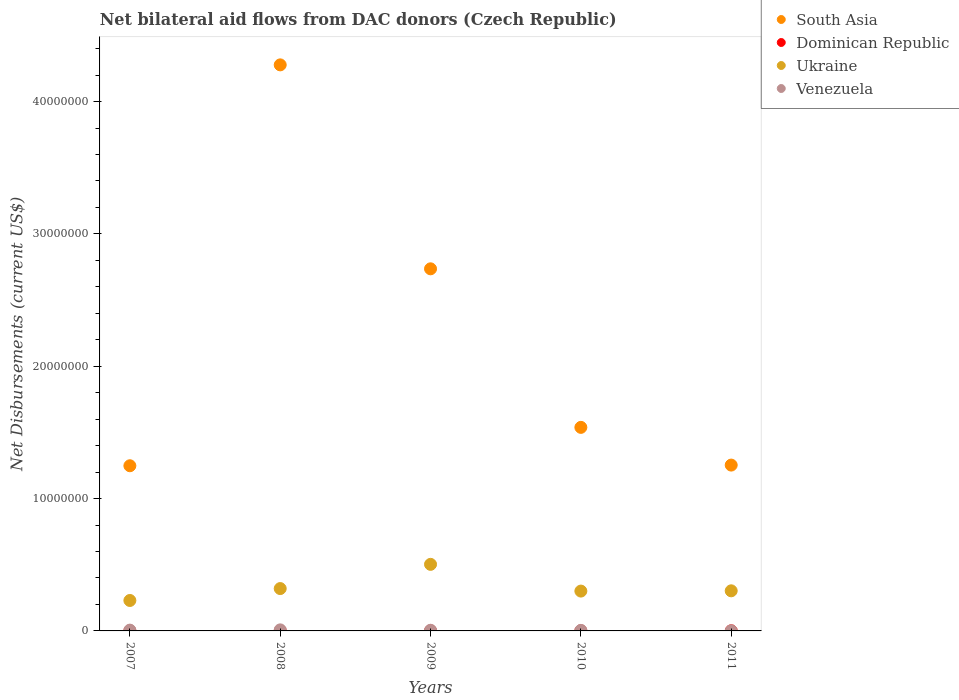What is the net bilateral aid flows in Ukraine in 2007?
Keep it short and to the point. 2.30e+06. Across all years, what is the minimum net bilateral aid flows in Ukraine?
Your response must be concise. 2.30e+06. In which year was the net bilateral aid flows in South Asia maximum?
Your answer should be compact. 2008. What is the total net bilateral aid flows in Ukraine in the graph?
Make the answer very short. 1.66e+07. What is the difference between the net bilateral aid flows in Ukraine in 2011 and the net bilateral aid flows in Venezuela in 2010?
Ensure brevity in your answer.  2.99e+06. What is the average net bilateral aid flows in Ukraine per year?
Offer a terse response. 3.31e+06. In the year 2007, what is the difference between the net bilateral aid flows in Dominican Republic and net bilateral aid flows in Venezuela?
Offer a terse response. -5.00e+04. In how many years, is the net bilateral aid flows in Ukraine greater than 28000000 US$?
Offer a very short reply. 0. What is the ratio of the net bilateral aid flows in South Asia in 2007 to that in 2011?
Your answer should be very brief. 1. Is the net bilateral aid flows in Venezuela in 2007 less than that in 2008?
Ensure brevity in your answer.  Yes. Is the difference between the net bilateral aid flows in Dominican Republic in 2007 and 2010 greater than the difference between the net bilateral aid flows in Venezuela in 2007 and 2010?
Offer a terse response. No. What is the difference between the highest and the second highest net bilateral aid flows in Ukraine?
Your answer should be very brief. 1.83e+06. In how many years, is the net bilateral aid flows in Venezuela greater than the average net bilateral aid flows in Venezuela taken over all years?
Offer a terse response. 3. Is the sum of the net bilateral aid flows in Venezuela in 2008 and 2011 greater than the maximum net bilateral aid flows in Dominican Republic across all years?
Your response must be concise. Yes. Is it the case that in every year, the sum of the net bilateral aid flows in Venezuela and net bilateral aid flows in Ukraine  is greater than the sum of net bilateral aid flows in Dominican Republic and net bilateral aid flows in South Asia?
Provide a short and direct response. Yes. Is it the case that in every year, the sum of the net bilateral aid flows in Venezuela and net bilateral aid flows in South Asia  is greater than the net bilateral aid flows in Dominican Republic?
Keep it short and to the point. Yes. Does the net bilateral aid flows in Ukraine monotonically increase over the years?
Your answer should be compact. No. Is the net bilateral aid flows in Ukraine strictly less than the net bilateral aid flows in Dominican Republic over the years?
Offer a very short reply. No. What is the difference between two consecutive major ticks on the Y-axis?
Give a very brief answer. 1.00e+07. Are the values on the major ticks of Y-axis written in scientific E-notation?
Provide a succinct answer. No. Does the graph contain grids?
Provide a short and direct response. No. How many legend labels are there?
Ensure brevity in your answer.  4. What is the title of the graph?
Provide a succinct answer. Net bilateral aid flows from DAC donors (Czech Republic). Does "Guinea" appear as one of the legend labels in the graph?
Keep it short and to the point. No. What is the label or title of the Y-axis?
Ensure brevity in your answer.  Net Disbursements (current US$). What is the Net Disbursements (current US$) in South Asia in 2007?
Make the answer very short. 1.25e+07. What is the Net Disbursements (current US$) of Dominican Republic in 2007?
Keep it short and to the point. 10000. What is the Net Disbursements (current US$) in Ukraine in 2007?
Your answer should be compact. 2.30e+06. What is the Net Disbursements (current US$) of Venezuela in 2007?
Your response must be concise. 6.00e+04. What is the Net Disbursements (current US$) of South Asia in 2008?
Provide a succinct answer. 4.28e+07. What is the Net Disbursements (current US$) of Dominican Republic in 2008?
Make the answer very short. 10000. What is the Net Disbursements (current US$) of Ukraine in 2008?
Keep it short and to the point. 3.20e+06. What is the Net Disbursements (current US$) in Venezuela in 2008?
Your response must be concise. 8.00e+04. What is the Net Disbursements (current US$) in South Asia in 2009?
Keep it short and to the point. 2.74e+07. What is the Net Disbursements (current US$) of Dominican Republic in 2009?
Make the answer very short. 10000. What is the Net Disbursements (current US$) of Ukraine in 2009?
Provide a succinct answer. 5.03e+06. What is the Net Disbursements (current US$) in South Asia in 2010?
Your answer should be very brief. 1.54e+07. What is the Net Disbursements (current US$) of Ukraine in 2010?
Your answer should be compact. 3.01e+06. What is the Net Disbursements (current US$) of South Asia in 2011?
Make the answer very short. 1.25e+07. What is the Net Disbursements (current US$) of Dominican Republic in 2011?
Offer a very short reply. 10000. What is the Net Disbursements (current US$) of Ukraine in 2011?
Keep it short and to the point. 3.03e+06. Across all years, what is the maximum Net Disbursements (current US$) in South Asia?
Your response must be concise. 4.28e+07. Across all years, what is the maximum Net Disbursements (current US$) of Dominican Republic?
Offer a very short reply. 10000. Across all years, what is the maximum Net Disbursements (current US$) in Ukraine?
Offer a terse response. 5.03e+06. Across all years, what is the maximum Net Disbursements (current US$) in Venezuela?
Give a very brief answer. 8.00e+04. Across all years, what is the minimum Net Disbursements (current US$) in South Asia?
Keep it short and to the point. 1.25e+07. Across all years, what is the minimum Net Disbursements (current US$) in Ukraine?
Offer a very short reply. 2.30e+06. What is the total Net Disbursements (current US$) of South Asia in the graph?
Make the answer very short. 1.11e+08. What is the total Net Disbursements (current US$) in Dominican Republic in the graph?
Give a very brief answer. 5.00e+04. What is the total Net Disbursements (current US$) of Ukraine in the graph?
Make the answer very short. 1.66e+07. What is the total Net Disbursements (current US$) in Venezuela in the graph?
Provide a short and direct response. 2.40e+05. What is the difference between the Net Disbursements (current US$) in South Asia in 2007 and that in 2008?
Offer a terse response. -3.03e+07. What is the difference between the Net Disbursements (current US$) in Ukraine in 2007 and that in 2008?
Offer a terse response. -9.00e+05. What is the difference between the Net Disbursements (current US$) of Venezuela in 2007 and that in 2008?
Your answer should be very brief. -2.00e+04. What is the difference between the Net Disbursements (current US$) of South Asia in 2007 and that in 2009?
Your answer should be very brief. -1.49e+07. What is the difference between the Net Disbursements (current US$) of Ukraine in 2007 and that in 2009?
Make the answer very short. -2.73e+06. What is the difference between the Net Disbursements (current US$) of South Asia in 2007 and that in 2010?
Provide a succinct answer. -2.90e+06. What is the difference between the Net Disbursements (current US$) of Dominican Republic in 2007 and that in 2010?
Make the answer very short. 0. What is the difference between the Net Disbursements (current US$) of Ukraine in 2007 and that in 2010?
Offer a very short reply. -7.10e+05. What is the difference between the Net Disbursements (current US$) of Venezuela in 2007 and that in 2010?
Offer a very short reply. 2.00e+04. What is the difference between the Net Disbursements (current US$) in South Asia in 2007 and that in 2011?
Offer a terse response. -5.00e+04. What is the difference between the Net Disbursements (current US$) of Dominican Republic in 2007 and that in 2011?
Give a very brief answer. 0. What is the difference between the Net Disbursements (current US$) in Ukraine in 2007 and that in 2011?
Provide a short and direct response. -7.30e+05. What is the difference between the Net Disbursements (current US$) of South Asia in 2008 and that in 2009?
Provide a short and direct response. 1.54e+07. What is the difference between the Net Disbursements (current US$) in Ukraine in 2008 and that in 2009?
Offer a terse response. -1.83e+06. What is the difference between the Net Disbursements (current US$) of Venezuela in 2008 and that in 2009?
Your answer should be compact. 3.00e+04. What is the difference between the Net Disbursements (current US$) of South Asia in 2008 and that in 2010?
Ensure brevity in your answer.  2.74e+07. What is the difference between the Net Disbursements (current US$) of Venezuela in 2008 and that in 2010?
Ensure brevity in your answer.  4.00e+04. What is the difference between the Net Disbursements (current US$) in South Asia in 2008 and that in 2011?
Keep it short and to the point. 3.02e+07. What is the difference between the Net Disbursements (current US$) in Ukraine in 2008 and that in 2011?
Make the answer very short. 1.70e+05. What is the difference between the Net Disbursements (current US$) of South Asia in 2009 and that in 2010?
Your response must be concise. 1.20e+07. What is the difference between the Net Disbursements (current US$) in Ukraine in 2009 and that in 2010?
Your answer should be compact. 2.02e+06. What is the difference between the Net Disbursements (current US$) in Venezuela in 2009 and that in 2010?
Provide a short and direct response. 10000. What is the difference between the Net Disbursements (current US$) in South Asia in 2009 and that in 2011?
Keep it short and to the point. 1.48e+07. What is the difference between the Net Disbursements (current US$) in Ukraine in 2009 and that in 2011?
Provide a succinct answer. 2.00e+06. What is the difference between the Net Disbursements (current US$) of South Asia in 2010 and that in 2011?
Your response must be concise. 2.85e+06. What is the difference between the Net Disbursements (current US$) in Ukraine in 2010 and that in 2011?
Your answer should be very brief. -2.00e+04. What is the difference between the Net Disbursements (current US$) in South Asia in 2007 and the Net Disbursements (current US$) in Dominican Republic in 2008?
Keep it short and to the point. 1.25e+07. What is the difference between the Net Disbursements (current US$) in South Asia in 2007 and the Net Disbursements (current US$) in Ukraine in 2008?
Provide a succinct answer. 9.28e+06. What is the difference between the Net Disbursements (current US$) in South Asia in 2007 and the Net Disbursements (current US$) in Venezuela in 2008?
Ensure brevity in your answer.  1.24e+07. What is the difference between the Net Disbursements (current US$) in Dominican Republic in 2007 and the Net Disbursements (current US$) in Ukraine in 2008?
Offer a very short reply. -3.19e+06. What is the difference between the Net Disbursements (current US$) of Ukraine in 2007 and the Net Disbursements (current US$) of Venezuela in 2008?
Offer a very short reply. 2.22e+06. What is the difference between the Net Disbursements (current US$) in South Asia in 2007 and the Net Disbursements (current US$) in Dominican Republic in 2009?
Provide a short and direct response. 1.25e+07. What is the difference between the Net Disbursements (current US$) of South Asia in 2007 and the Net Disbursements (current US$) of Ukraine in 2009?
Your response must be concise. 7.45e+06. What is the difference between the Net Disbursements (current US$) of South Asia in 2007 and the Net Disbursements (current US$) of Venezuela in 2009?
Your answer should be very brief. 1.24e+07. What is the difference between the Net Disbursements (current US$) in Dominican Republic in 2007 and the Net Disbursements (current US$) in Ukraine in 2009?
Keep it short and to the point. -5.02e+06. What is the difference between the Net Disbursements (current US$) of Dominican Republic in 2007 and the Net Disbursements (current US$) of Venezuela in 2009?
Provide a succinct answer. -4.00e+04. What is the difference between the Net Disbursements (current US$) of Ukraine in 2007 and the Net Disbursements (current US$) of Venezuela in 2009?
Provide a succinct answer. 2.25e+06. What is the difference between the Net Disbursements (current US$) of South Asia in 2007 and the Net Disbursements (current US$) of Dominican Republic in 2010?
Offer a very short reply. 1.25e+07. What is the difference between the Net Disbursements (current US$) in South Asia in 2007 and the Net Disbursements (current US$) in Ukraine in 2010?
Offer a very short reply. 9.47e+06. What is the difference between the Net Disbursements (current US$) in South Asia in 2007 and the Net Disbursements (current US$) in Venezuela in 2010?
Your answer should be compact. 1.24e+07. What is the difference between the Net Disbursements (current US$) of Dominican Republic in 2007 and the Net Disbursements (current US$) of Ukraine in 2010?
Give a very brief answer. -3.00e+06. What is the difference between the Net Disbursements (current US$) in Dominican Republic in 2007 and the Net Disbursements (current US$) in Venezuela in 2010?
Ensure brevity in your answer.  -3.00e+04. What is the difference between the Net Disbursements (current US$) in Ukraine in 2007 and the Net Disbursements (current US$) in Venezuela in 2010?
Your answer should be compact. 2.26e+06. What is the difference between the Net Disbursements (current US$) in South Asia in 2007 and the Net Disbursements (current US$) in Dominican Republic in 2011?
Ensure brevity in your answer.  1.25e+07. What is the difference between the Net Disbursements (current US$) in South Asia in 2007 and the Net Disbursements (current US$) in Ukraine in 2011?
Your answer should be very brief. 9.45e+06. What is the difference between the Net Disbursements (current US$) in South Asia in 2007 and the Net Disbursements (current US$) in Venezuela in 2011?
Give a very brief answer. 1.25e+07. What is the difference between the Net Disbursements (current US$) of Dominican Republic in 2007 and the Net Disbursements (current US$) of Ukraine in 2011?
Ensure brevity in your answer.  -3.02e+06. What is the difference between the Net Disbursements (current US$) of Dominican Republic in 2007 and the Net Disbursements (current US$) of Venezuela in 2011?
Provide a succinct answer. 0. What is the difference between the Net Disbursements (current US$) of Ukraine in 2007 and the Net Disbursements (current US$) of Venezuela in 2011?
Offer a very short reply. 2.29e+06. What is the difference between the Net Disbursements (current US$) of South Asia in 2008 and the Net Disbursements (current US$) of Dominican Republic in 2009?
Offer a very short reply. 4.28e+07. What is the difference between the Net Disbursements (current US$) of South Asia in 2008 and the Net Disbursements (current US$) of Ukraine in 2009?
Your answer should be compact. 3.77e+07. What is the difference between the Net Disbursements (current US$) in South Asia in 2008 and the Net Disbursements (current US$) in Venezuela in 2009?
Keep it short and to the point. 4.27e+07. What is the difference between the Net Disbursements (current US$) in Dominican Republic in 2008 and the Net Disbursements (current US$) in Ukraine in 2009?
Provide a succinct answer. -5.02e+06. What is the difference between the Net Disbursements (current US$) of Ukraine in 2008 and the Net Disbursements (current US$) of Venezuela in 2009?
Your answer should be very brief. 3.15e+06. What is the difference between the Net Disbursements (current US$) of South Asia in 2008 and the Net Disbursements (current US$) of Dominican Republic in 2010?
Provide a short and direct response. 4.28e+07. What is the difference between the Net Disbursements (current US$) of South Asia in 2008 and the Net Disbursements (current US$) of Ukraine in 2010?
Your answer should be very brief. 3.98e+07. What is the difference between the Net Disbursements (current US$) of South Asia in 2008 and the Net Disbursements (current US$) of Venezuela in 2010?
Offer a terse response. 4.27e+07. What is the difference between the Net Disbursements (current US$) of Dominican Republic in 2008 and the Net Disbursements (current US$) of Ukraine in 2010?
Provide a short and direct response. -3.00e+06. What is the difference between the Net Disbursements (current US$) of Dominican Republic in 2008 and the Net Disbursements (current US$) of Venezuela in 2010?
Provide a short and direct response. -3.00e+04. What is the difference between the Net Disbursements (current US$) of Ukraine in 2008 and the Net Disbursements (current US$) of Venezuela in 2010?
Your answer should be very brief. 3.16e+06. What is the difference between the Net Disbursements (current US$) in South Asia in 2008 and the Net Disbursements (current US$) in Dominican Republic in 2011?
Your response must be concise. 4.28e+07. What is the difference between the Net Disbursements (current US$) of South Asia in 2008 and the Net Disbursements (current US$) of Ukraine in 2011?
Your answer should be compact. 3.97e+07. What is the difference between the Net Disbursements (current US$) in South Asia in 2008 and the Net Disbursements (current US$) in Venezuela in 2011?
Your answer should be very brief. 4.28e+07. What is the difference between the Net Disbursements (current US$) of Dominican Republic in 2008 and the Net Disbursements (current US$) of Ukraine in 2011?
Your response must be concise. -3.02e+06. What is the difference between the Net Disbursements (current US$) of Dominican Republic in 2008 and the Net Disbursements (current US$) of Venezuela in 2011?
Give a very brief answer. 0. What is the difference between the Net Disbursements (current US$) of Ukraine in 2008 and the Net Disbursements (current US$) of Venezuela in 2011?
Provide a succinct answer. 3.19e+06. What is the difference between the Net Disbursements (current US$) in South Asia in 2009 and the Net Disbursements (current US$) in Dominican Republic in 2010?
Offer a very short reply. 2.74e+07. What is the difference between the Net Disbursements (current US$) of South Asia in 2009 and the Net Disbursements (current US$) of Ukraine in 2010?
Your answer should be compact. 2.44e+07. What is the difference between the Net Disbursements (current US$) in South Asia in 2009 and the Net Disbursements (current US$) in Venezuela in 2010?
Make the answer very short. 2.73e+07. What is the difference between the Net Disbursements (current US$) of Dominican Republic in 2009 and the Net Disbursements (current US$) of Ukraine in 2010?
Make the answer very short. -3.00e+06. What is the difference between the Net Disbursements (current US$) of Ukraine in 2009 and the Net Disbursements (current US$) of Venezuela in 2010?
Offer a very short reply. 4.99e+06. What is the difference between the Net Disbursements (current US$) in South Asia in 2009 and the Net Disbursements (current US$) in Dominican Republic in 2011?
Offer a terse response. 2.74e+07. What is the difference between the Net Disbursements (current US$) in South Asia in 2009 and the Net Disbursements (current US$) in Ukraine in 2011?
Your answer should be very brief. 2.43e+07. What is the difference between the Net Disbursements (current US$) in South Asia in 2009 and the Net Disbursements (current US$) in Venezuela in 2011?
Your response must be concise. 2.74e+07. What is the difference between the Net Disbursements (current US$) in Dominican Republic in 2009 and the Net Disbursements (current US$) in Ukraine in 2011?
Give a very brief answer. -3.02e+06. What is the difference between the Net Disbursements (current US$) of Ukraine in 2009 and the Net Disbursements (current US$) of Venezuela in 2011?
Provide a succinct answer. 5.02e+06. What is the difference between the Net Disbursements (current US$) in South Asia in 2010 and the Net Disbursements (current US$) in Dominican Republic in 2011?
Your answer should be very brief. 1.54e+07. What is the difference between the Net Disbursements (current US$) in South Asia in 2010 and the Net Disbursements (current US$) in Ukraine in 2011?
Your response must be concise. 1.24e+07. What is the difference between the Net Disbursements (current US$) of South Asia in 2010 and the Net Disbursements (current US$) of Venezuela in 2011?
Your response must be concise. 1.54e+07. What is the difference between the Net Disbursements (current US$) of Dominican Republic in 2010 and the Net Disbursements (current US$) of Ukraine in 2011?
Provide a short and direct response. -3.02e+06. What is the difference between the Net Disbursements (current US$) of Ukraine in 2010 and the Net Disbursements (current US$) of Venezuela in 2011?
Provide a succinct answer. 3.00e+06. What is the average Net Disbursements (current US$) in South Asia per year?
Give a very brief answer. 2.21e+07. What is the average Net Disbursements (current US$) in Ukraine per year?
Provide a short and direct response. 3.31e+06. What is the average Net Disbursements (current US$) in Venezuela per year?
Your answer should be very brief. 4.80e+04. In the year 2007, what is the difference between the Net Disbursements (current US$) in South Asia and Net Disbursements (current US$) in Dominican Republic?
Keep it short and to the point. 1.25e+07. In the year 2007, what is the difference between the Net Disbursements (current US$) of South Asia and Net Disbursements (current US$) of Ukraine?
Offer a terse response. 1.02e+07. In the year 2007, what is the difference between the Net Disbursements (current US$) of South Asia and Net Disbursements (current US$) of Venezuela?
Provide a succinct answer. 1.24e+07. In the year 2007, what is the difference between the Net Disbursements (current US$) in Dominican Republic and Net Disbursements (current US$) in Ukraine?
Ensure brevity in your answer.  -2.29e+06. In the year 2007, what is the difference between the Net Disbursements (current US$) of Dominican Republic and Net Disbursements (current US$) of Venezuela?
Offer a terse response. -5.00e+04. In the year 2007, what is the difference between the Net Disbursements (current US$) of Ukraine and Net Disbursements (current US$) of Venezuela?
Ensure brevity in your answer.  2.24e+06. In the year 2008, what is the difference between the Net Disbursements (current US$) in South Asia and Net Disbursements (current US$) in Dominican Republic?
Your answer should be very brief. 4.28e+07. In the year 2008, what is the difference between the Net Disbursements (current US$) of South Asia and Net Disbursements (current US$) of Ukraine?
Provide a succinct answer. 3.96e+07. In the year 2008, what is the difference between the Net Disbursements (current US$) of South Asia and Net Disbursements (current US$) of Venezuela?
Your response must be concise. 4.27e+07. In the year 2008, what is the difference between the Net Disbursements (current US$) in Dominican Republic and Net Disbursements (current US$) in Ukraine?
Provide a short and direct response. -3.19e+06. In the year 2008, what is the difference between the Net Disbursements (current US$) in Dominican Republic and Net Disbursements (current US$) in Venezuela?
Ensure brevity in your answer.  -7.00e+04. In the year 2008, what is the difference between the Net Disbursements (current US$) in Ukraine and Net Disbursements (current US$) in Venezuela?
Your answer should be very brief. 3.12e+06. In the year 2009, what is the difference between the Net Disbursements (current US$) in South Asia and Net Disbursements (current US$) in Dominican Republic?
Give a very brief answer. 2.74e+07. In the year 2009, what is the difference between the Net Disbursements (current US$) in South Asia and Net Disbursements (current US$) in Ukraine?
Provide a succinct answer. 2.23e+07. In the year 2009, what is the difference between the Net Disbursements (current US$) of South Asia and Net Disbursements (current US$) of Venezuela?
Your answer should be compact. 2.73e+07. In the year 2009, what is the difference between the Net Disbursements (current US$) of Dominican Republic and Net Disbursements (current US$) of Ukraine?
Give a very brief answer. -5.02e+06. In the year 2009, what is the difference between the Net Disbursements (current US$) in Dominican Republic and Net Disbursements (current US$) in Venezuela?
Offer a terse response. -4.00e+04. In the year 2009, what is the difference between the Net Disbursements (current US$) in Ukraine and Net Disbursements (current US$) in Venezuela?
Your answer should be very brief. 4.98e+06. In the year 2010, what is the difference between the Net Disbursements (current US$) in South Asia and Net Disbursements (current US$) in Dominican Republic?
Provide a short and direct response. 1.54e+07. In the year 2010, what is the difference between the Net Disbursements (current US$) in South Asia and Net Disbursements (current US$) in Ukraine?
Your answer should be compact. 1.24e+07. In the year 2010, what is the difference between the Net Disbursements (current US$) in South Asia and Net Disbursements (current US$) in Venezuela?
Provide a short and direct response. 1.53e+07. In the year 2010, what is the difference between the Net Disbursements (current US$) of Dominican Republic and Net Disbursements (current US$) of Venezuela?
Your response must be concise. -3.00e+04. In the year 2010, what is the difference between the Net Disbursements (current US$) of Ukraine and Net Disbursements (current US$) of Venezuela?
Offer a very short reply. 2.97e+06. In the year 2011, what is the difference between the Net Disbursements (current US$) in South Asia and Net Disbursements (current US$) in Dominican Republic?
Your answer should be very brief. 1.25e+07. In the year 2011, what is the difference between the Net Disbursements (current US$) of South Asia and Net Disbursements (current US$) of Ukraine?
Ensure brevity in your answer.  9.50e+06. In the year 2011, what is the difference between the Net Disbursements (current US$) of South Asia and Net Disbursements (current US$) of Venezuela?
Make the answer very short. 1.25e+07. In the year 2011, what is the difference between the Net Disbursements (current US$) of Dominican Republic and Net Disbursements (current US$) of Ukraine?
Your answer should be compact. -3.02e+06. In the year 2011, what is the difference between the Net Disbursements (current US$) in Dominican Republic and Net Disbursements (current US$) in Venezuela?
Your response must be concise. 0. In the year 2011, what is the difference between the Net Disbursements (current US$) in Ukraine and Net Disbursements (current US$) in Venezuela?
Offer a very short reply. 3.02e+06. What is the ratio of the Net Disbursements (current US$) in South Asia in 2007 to that in 2008?
Your answer should be compact. 0.29. What is the ratio of the Net Disbursements (current US$) in Ukraine in 2007 to that in 2008?
Your answer should be very brief. 0.72. What is the ratio of the Net Disbursements (current US$) of Venezuela in 2007 to that in 2008?
Provide a succinct answer. 0.75. What is the ratio of the Net Disbursements (current US$) of South Asia in 2007 to that in 2009?
Your response must be concise. 0.46. What is the ratio of the Net Disbursements (current US$) in Dominican Republic in 2007 to that in 2009?
Offer a very short reply. 1. What is the ratio of the Net Disbursements (current US$) of Ukraine in 2007 to that in 2009?
Ensure brevity in your answer.  0.46. What is the ratio of the Net Disbursements (current US$) in South Asia in 2007 to that in 2010?
Keep it short and to the point. 0.81. What is the ratio of the Net Disbursements (current US$) of Dominican Republic in 2007 to that in 2010?
Ensure brevity in your answer.  1. What is the ratio of the Net Disbursements (current US$) of Ukraine in 2007 to that in 2010?
Your answer should be very brief. 0.76. What is the ratio of the Net Disbursements (current US$) in Venezuela in 2007 to that in 2010?
Provide a short and direct response. 1.5. What is the ratio of the Net Disbursements (current US$) in Dominican Republic in 2007 to that in 2011?
Offer a very short reply. 1. What is the ratio of the Net Disbursements (current US$) in Ukraine in 2007 to that in 2011?
Your response must be concise. 0.76. What is the ratio of the Net Disbursements (current US$) in Venezuela in 2007 to that in 2011?
Your answer should be compact. 6. What is the ratio of the Net Disbursements (current US$) in South Asia in 2008 to that in 2009?
Your answer should be compact. 1.56. What is the ratio of the Net Disbursements (current US$) of Dominican Republic in 2008 to that in 2009?
Your answer should be very brief. 1. What is the ratio of the Net Disbursements (current US$) in Ukraine in 2008 to that in 2009?
Offer a very short reply. 0.64. What is the ratio of the Net Disbursements (current US$) in South Asia in 2008 to that in 2010?
Provide a short and direct response. 2.78. What is the ratio of the Net Disbursements (current US$) of Ukraine in 2008 to that in 2010?
Provide a succinct answer. 1.06. What is the ratio of the Net Disbursements (current US$) in South Asia in 2008 to that in 2011?
Make the answer very short. 3.41. What is the ratio of the Net Disbursements (current US$) in Ukraine in 2008 to that in 2011?
Offer a very short reply. 1.06. What is the ratio of the Net Disbursements (current US$) of South Asia in 2009 to that in 2010?
Ensure brevity in your answer.  1.78. What is the ratio of the Net Disbursements (current US$) in Ukraine in 2009 to that in 2010?
Your response must be concise. 1.67. What is the ratio of the Net Disbursements (current US$) of South Asia in 2009 to that in 2011?
Ensure brevity in your answer.  2.18. What is the ratio of the Net Disbursements (current US$) of Dominican Republic in 2009 to that in 2011?
Your answer should be very brief. 1. What is the ratio of the Net Disbursements (current US$) of Ukraine in 2009 to that in 2011?
Your response must be concise. 1.66. What is the ratio of the Net Disbursements (current US$) in Venezuela in 2009 to that in 2011?
Offer a terse response. 5. What is the ratio of the Net Disbursements (current US$) of South Asia in 2010 to that in 2011?
Provide a short and direct response. 1.23. What is the ratio of the Net Disbursements (current US$) in Dominican Republic in 2010 to that in 2011?
Make the answer very short. 1. What is the ratio of the Net Disbursements (current US$) in Ukraine in 2010 to that in 2011?
Your response must be concise. 0.99. What is the difference between the highest and the second highest Net Disbursements (current US$) in South Asia?
Give a very brief answer. 1.54e+07. What is the difference between the highest and the second highest Net Disbursements (current US$) of Ukraine?
Offer a very short reply. 1.83e+06. What is the difference between the highest and the lowest Net Disbursements (current US$) in South Asia?
Your response must be concise. 3.03e+07. What is the difference between the highest and the lowest Net Disbursements (current US$) of Dominican Republic?
Keep it short and to the point. 0. What is the difference between the highest and the lowest Net Disbursements (current US$) in Ukraine?
Give a very brief answer. 2.73e+06. 